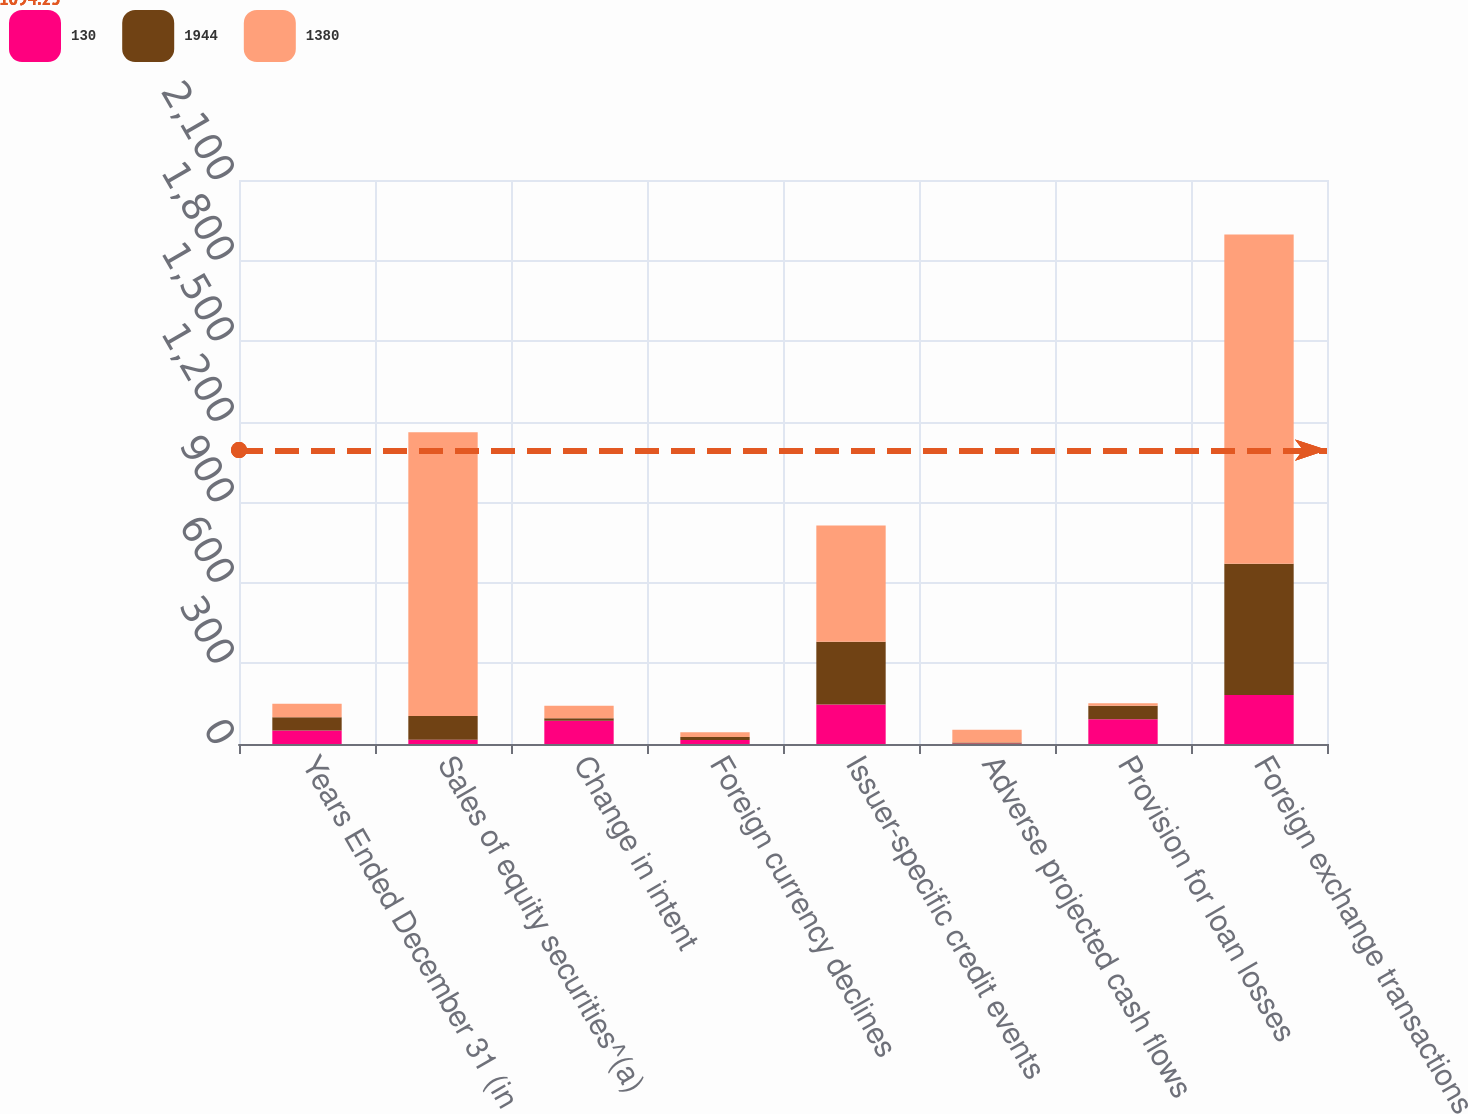<chart> <loc_0><loc_0><loc_500><loc_500><stacked_bar_chart><ecel><fcel>Years Ended December 31 (in<fcel>Sales of equity securities^(a)<fcel>Change in intent<fcel>Foreign currency declines<fcel>Issuer-specific credit events<fcel>Adverse projected cash flows<fcel>Provision for loan losses<fcel>Foreign exchange transactions<nl><fcel>130<fcel>50<fcel>16<fcel>87<fcel>15<fcel>147<fcel>2<fcel>92<fcel>182<nl><fcel>1944<fcel>50<fcel>88<fcel>9<fcel>11<fcel>234<fcel>4<fcel>50<fcel>489<nl><fcel>1380<fcel>50<fcel>1057<fcel>46<fcel>18<fcel>433<fcel>47<fcel>10<fcel>1226<nl></chart> 